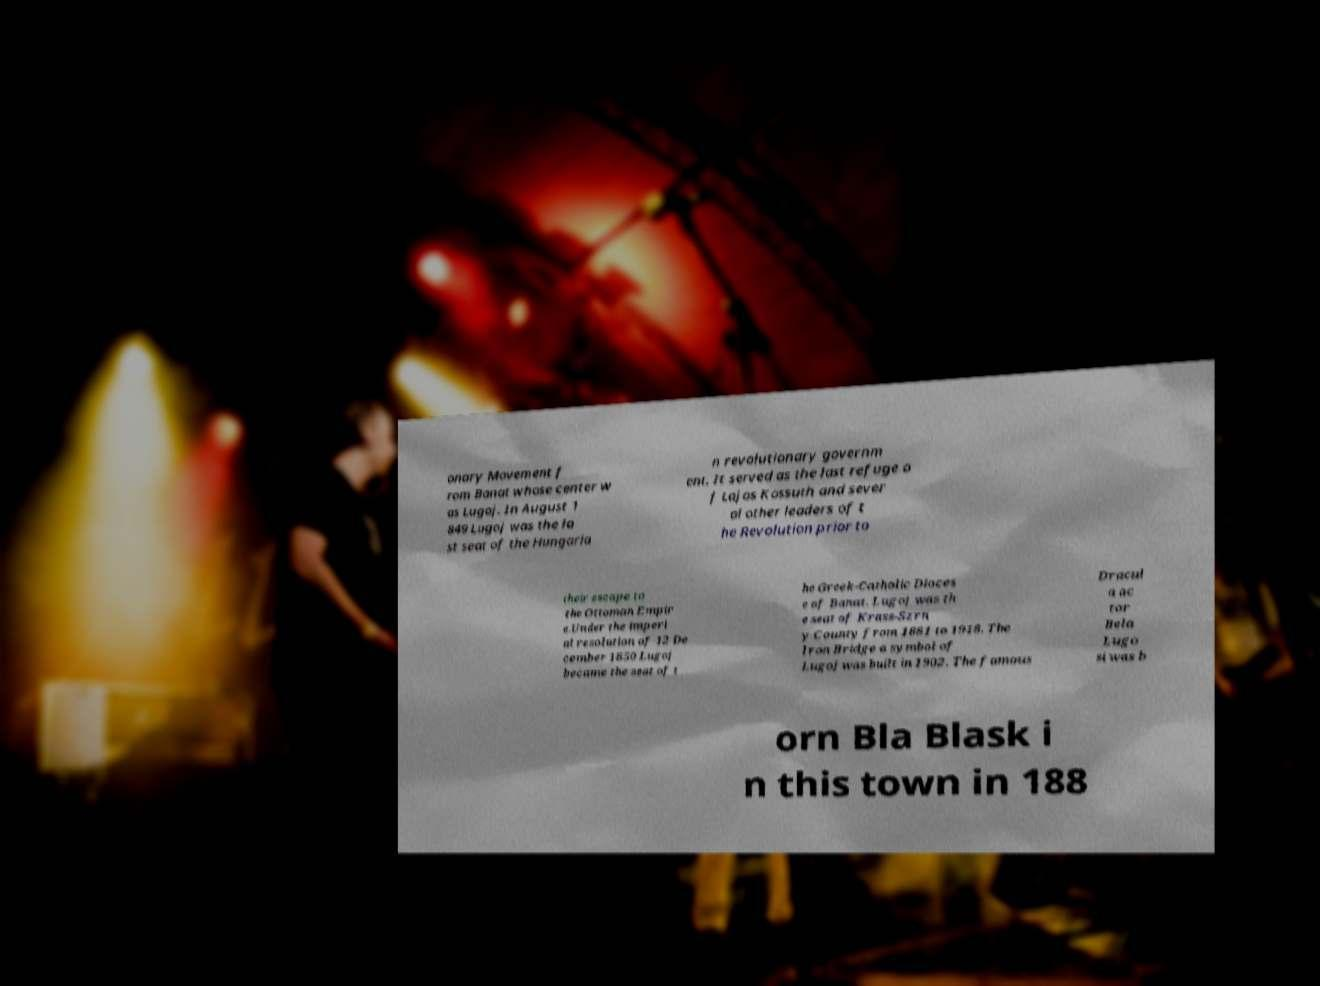Please read and relay the text visible in this image. What does it say? onary Movement f rom Banat whose center w as Lugoj. In August 1 849 Lugoj was the la st seat of the Hungaria n revolutionary governm ent. It served as the last refuge o f Lajos Kossuth and sever al other leaders of t he Revolution prior to their escape to the Ottoman Empir e.Under the imperi al resolution of 12 De cember 1850 Lugoj became the seat of t he Greek-Catholic Dioces e of Banat. Lugoj was th e seat of Krass-Szrn y County from 1881 to 1918. The Iron Bridge a symbol of Lugoj was built in 1902. The famous Dracul a ac tor Bela Lugo si was b orn Bla Blask i n this town in 188 